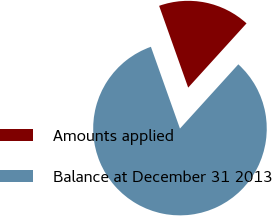<chart> <loc_0><loc_0><loc_500><loc_500><pie_chart><fcel>Amounts applied<fcel>Balance at December 31 2013<nl><fcel>17.17%<fcel>82.83%<nl></chart> 